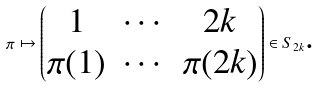Convert formula to latex. <formula><loc_0><loc_0><loc_500><loc_500>\pi \mapsto \begin{pmatrix} 1 & \cdots & 2 k \\ \pi ( 1 ) & \cdots & \pi ( 2 k ) \end{pmatrix} \in S _ { 2 k } \text {.}</formula> 